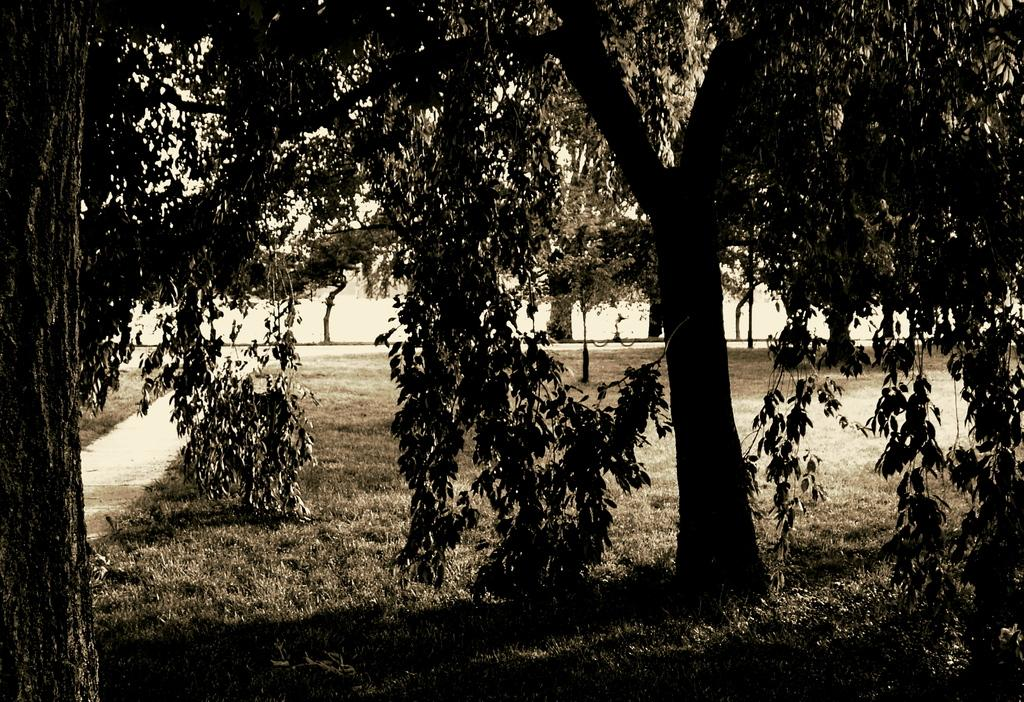What type of vegetation can be seen in the image? There are trees and grass in the image. Can you describe the natural environment depicted in the image? The image features trees and grass, which suggests a natural setting. How long does the wren take to fly across the image? There is no wren present in the image, so it is not possible to determine how long it would take for a wren to fly across the image. 